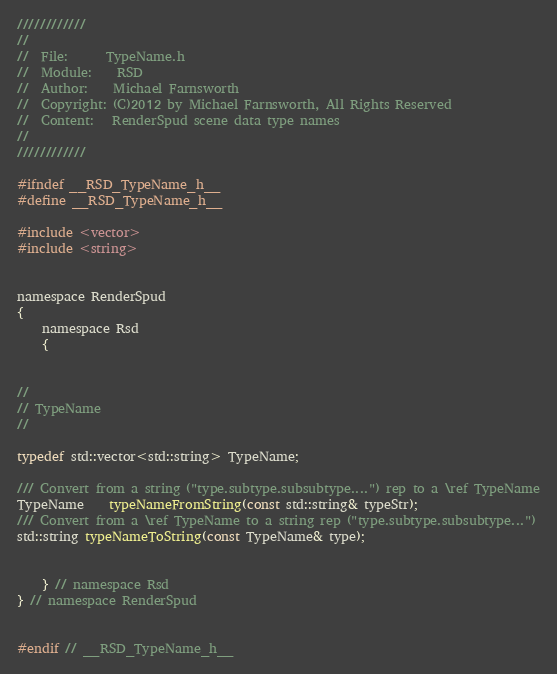Convert code to text. <code><loc_0><loc_0><loc_500><loc_500><_C_>////////////
//
//  File:      TypeName.h
//  Module:    RSD
//  Author:    Michael Farnsworth
//  Copyright: (C)2012 by Michael Farnsworth, All Rights Reserved
//  Content:   RenderSpud scene data type names
//
////////////

#ifndef __RSD_TypeName_h__
#define __RSD_TypeName_h__

#include <vector>
#include <string>


namespace RenderSpud
{
    namespace Rsd
    {


//
// TypeName
//

typedef std::vector<std::string> TypeName;

/// Convert from a string ("type.subtype.subsubtype....") rep to a \ref TypeName
TypeName    typeNameFromString(const std::string& typeStr);
/// Convert from a \ref TypeName to a string rep ("type.subtype.subsubtype...")
std::string typeNameToString(const TypeName& type);


    } // namespace Rsd
} // namespace RenderSpud


#endif // __RSD_TypeName_h__
</code> 